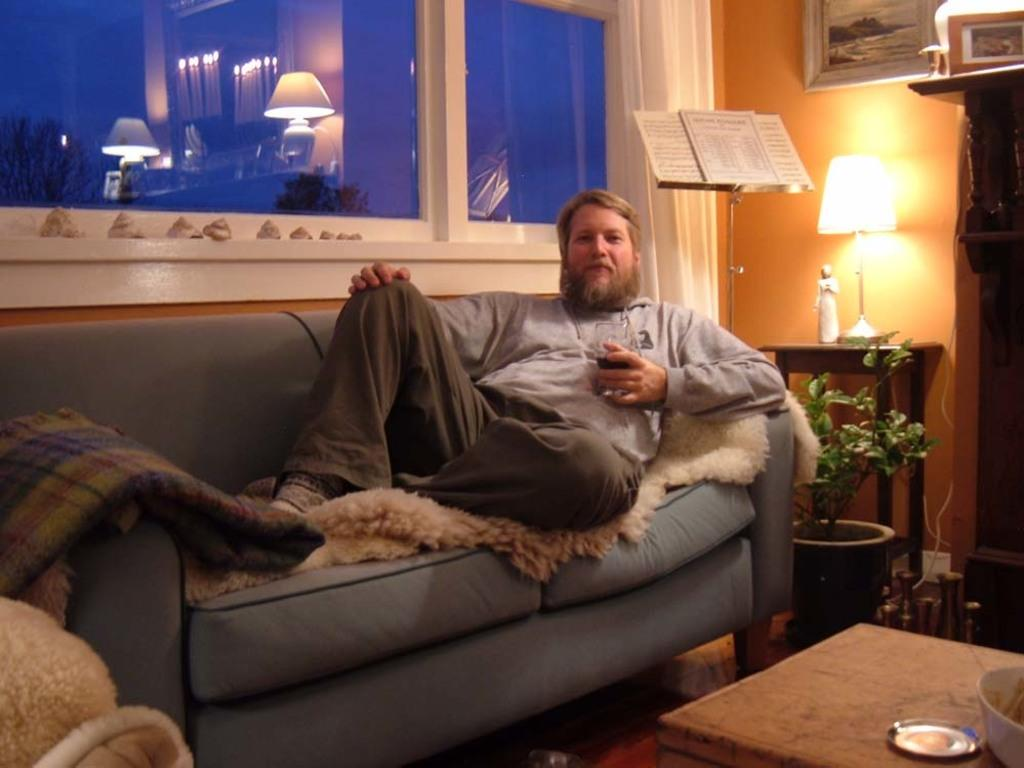What is the man in the image doing? The man is sitting on a couch in the image. What objects are on the table in the image? There is a bowl and a plate on a table in the image. What type of plant container is in the image? There is a flower pot in the image. What type of lighting fixture is in the image? There is a lamp in the image. What type of zipper can be seen on the man's clothing in the image? There is no zipper visible on the man's clothing in the image. What is the size of the farm depicted in the image? There is no farm present in the image. 